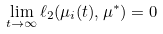<formula> <loc_0><loc_0><loc_500><loc_500>\lim _ { t \rightarrow \infty } \ell _ { 2 } ( \mu _ { i } ( t ) , \mu ^ { \ast } ) = 0</formula> 